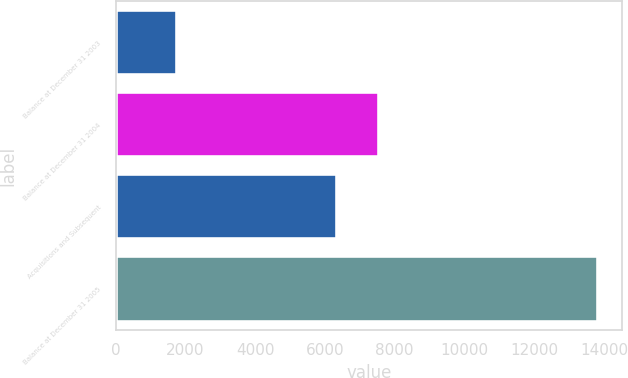Convert chart to OTSL. <chart><loc_0><loc_0><loc_500><loc_500><bar_chart><fcel>Balance at December 31 2003<fcel>Balance at December 31 2004<fcel>Acquisitions and Subsequent<fcel>Balance at December 31 2005<nl><fcel>1770<fcel>7546.4<fcel>6340<fcel>13834<nl></chart> 